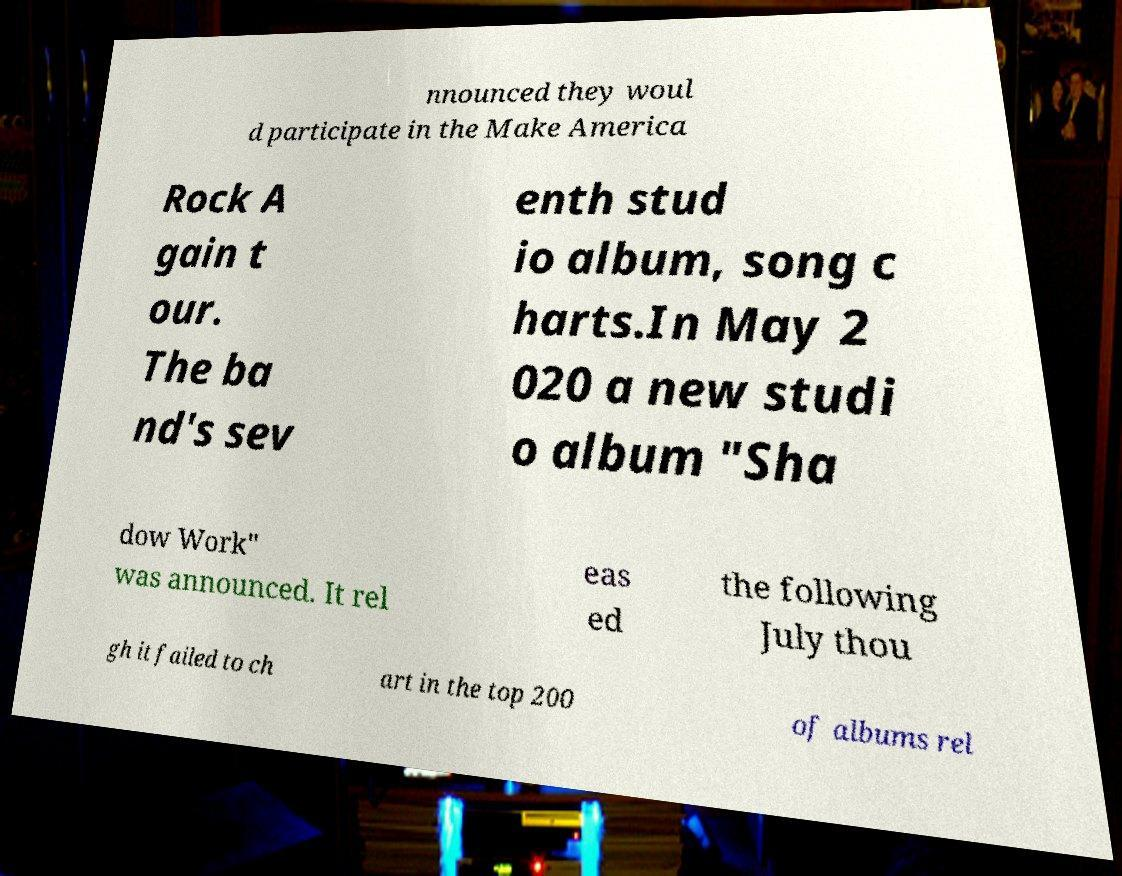What messages or text are displayed in this image? I need them in a readable, typed format. nnounced they woul d participate in the Make America Rock A gain t our. The ba nd's sev enth stud io album, song c harts.In May 2 020 a new studi o album "Sha dow Work" was announced. It rel eas ed the following July thou gh it failed to ch art in the top 200 of albums rel 